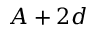Convert formula to latex. <formula><loc_0><loc_0><loc_500><loc_500>A + 2 d</formula> 